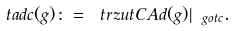<formula> <loc_0><loc_0><loc_500><loc_500>\ t a d c ( g ) \colon = \ t r z u t C A d ( g ) | _ { \ g o t c } .</formula> 